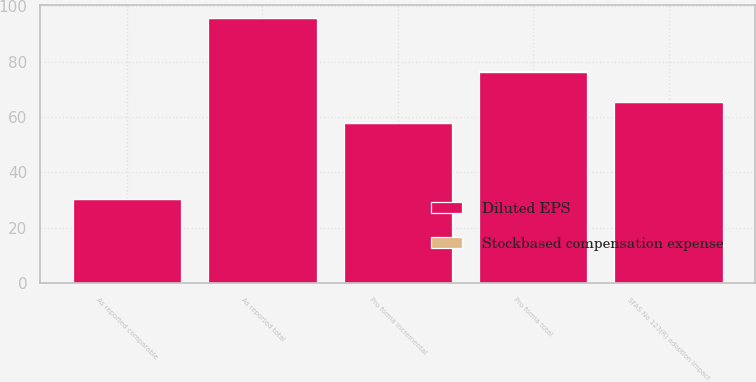Convert chart. <chart><loc_0><loc_0><loc_500><loc_500><stacked_bar_chart><ecel><fcel>As reported comparable<fcel>SFAS No 123(R) adoption impact<fcel>As reported total<fcel>Pro forma incremental<fcel>Pro forma total<nl><fcel>Diluted EPS<fcel>30.3<fcel>65.4<fcel>95.7<fcel>57.9<fcel>76.4<nl><fcel>Stockbased compensation expense<fcel>0.04<fcel>0.11<fcel>0.15<fcel>0.09<fcel>0.12<nl></chart> 